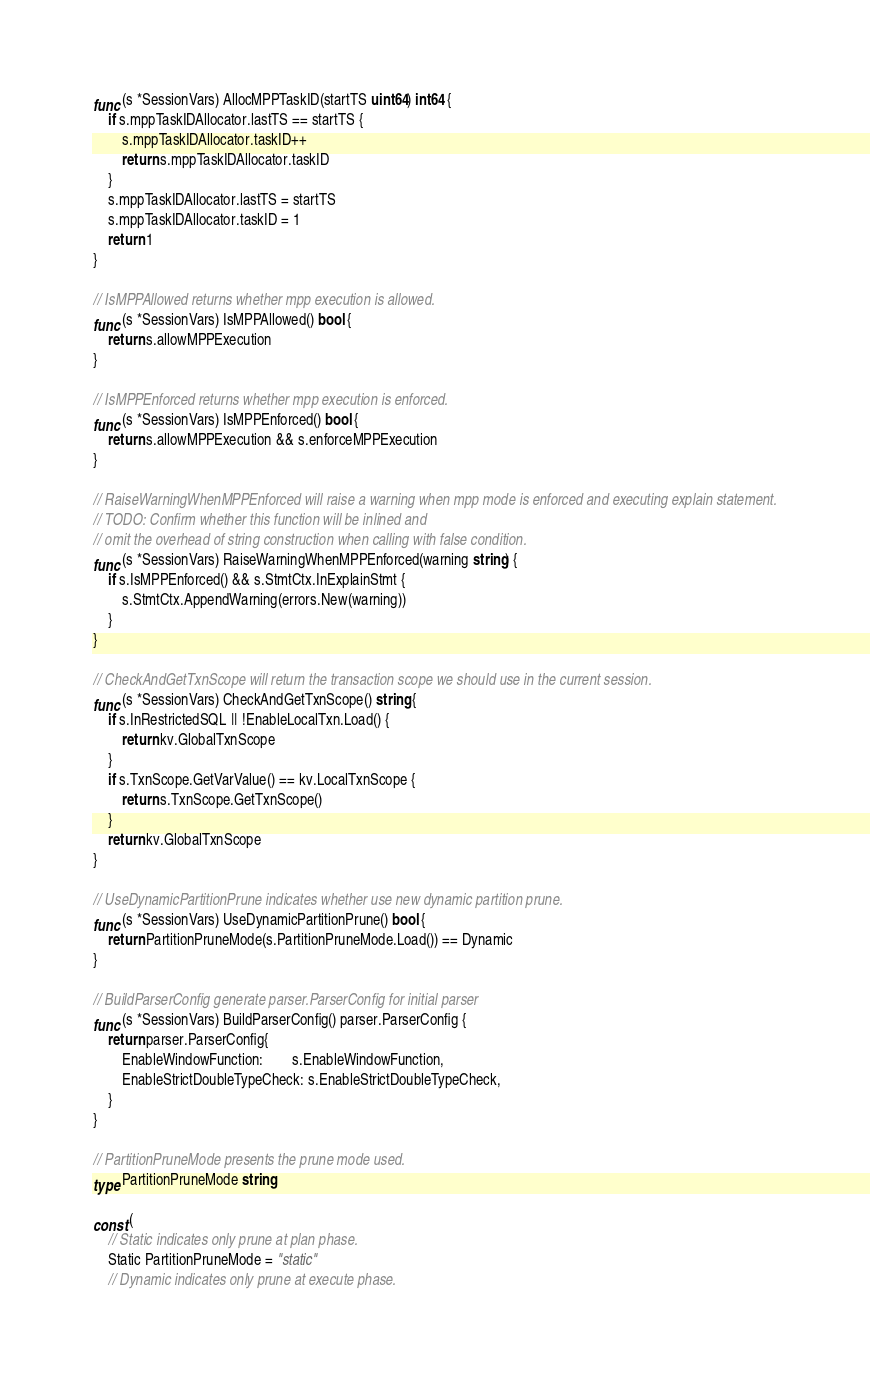Convert code to text. <code><loc_0><loc_0><loc_500><loc_500><_Go_>func (s *SessionVars) AllocMPPTaskID(startTS uint64) int64 {
	if s.mppTaskIDAllocator.lastTS == startTS {
		s.mppTaskIDAllocator.taskID++
		return s.mppTaskIDAllocator.taskID
	}
	s.mppTaskIDAllocator.lastTS = startTS
	s.mppTaskIDAllocator.taskID = 1
	return 1
}

// IsMPPAllowed returns whether mpp execution is allowed.
func (s *SessionVars) IsMPPAllowed() bool {
	return s.allowMPPExecution
}

// IsMPPEnforced returns whether mpp execution is enforced.
func (s *SessionVars) IsMPPEnforced() bool {
	return s.allowMPPExecution && s.enforceMPPExecution
}

// RaiseWarningWhenMPPEnforced will raise a warning when mpp mode is enforced and executing explain statement.
// TODO: Confirm whether this function will be inlined and
// omit the overhead of string construction when calling with false condition.
func (s *SessionVars) RaiseWarningWhenMPPEnforced(warning string) {
	if s.IsMPPEnforced() && s.StmtCtx.InExplainStmt {
		s.StmtCtx.AppendWarning(errors.New(warning))
	}
}

// CheckAndGetTxnScope will return the transaction scope we should use in the current session.
func (s *SessionVars) CheckAndGetTxnScope() string {
	if s.InRestrictedSQL || !EnableLocalTxn.Load() {
		return kv.GlobalTxnScope
	}
	if s.TxnScope.GetVarValue() == kv.LocalTxnScope {
		return s.TxnScope.GetTxnScope()
	}
	return kv.GlobalTxnScope
}

// UseDynamicPartitionPrune indicates whether use new dynamic partition prune.
func (s *SessionVars) UseDynamicPartitionPrune() bool {
	return PartitionPruneMode(s.PartitionPruneMode.Load()) == Dynamic
}

// BuildParserConfig generate parser.ParserConfig for initial parser
func (s *SessionVars) BuildParserConfig() parser.ParserConfig {
	return parser.ParserConfig{
		EnableWindowFunction:        s.EnableWindowFunction,
		EnableStrictDoubleTypeCheck: s.EnableStrictDoubleTypeCheck,
	}
}

// PartitionPruneMode presents the prune mode used.
type PartitionPruneMode string

const (
	// Static indicates only prune at plan phase.
	Static PartitionPruneMode = "static"
	// Dynamic indicates only prune at execute phase.</code> 